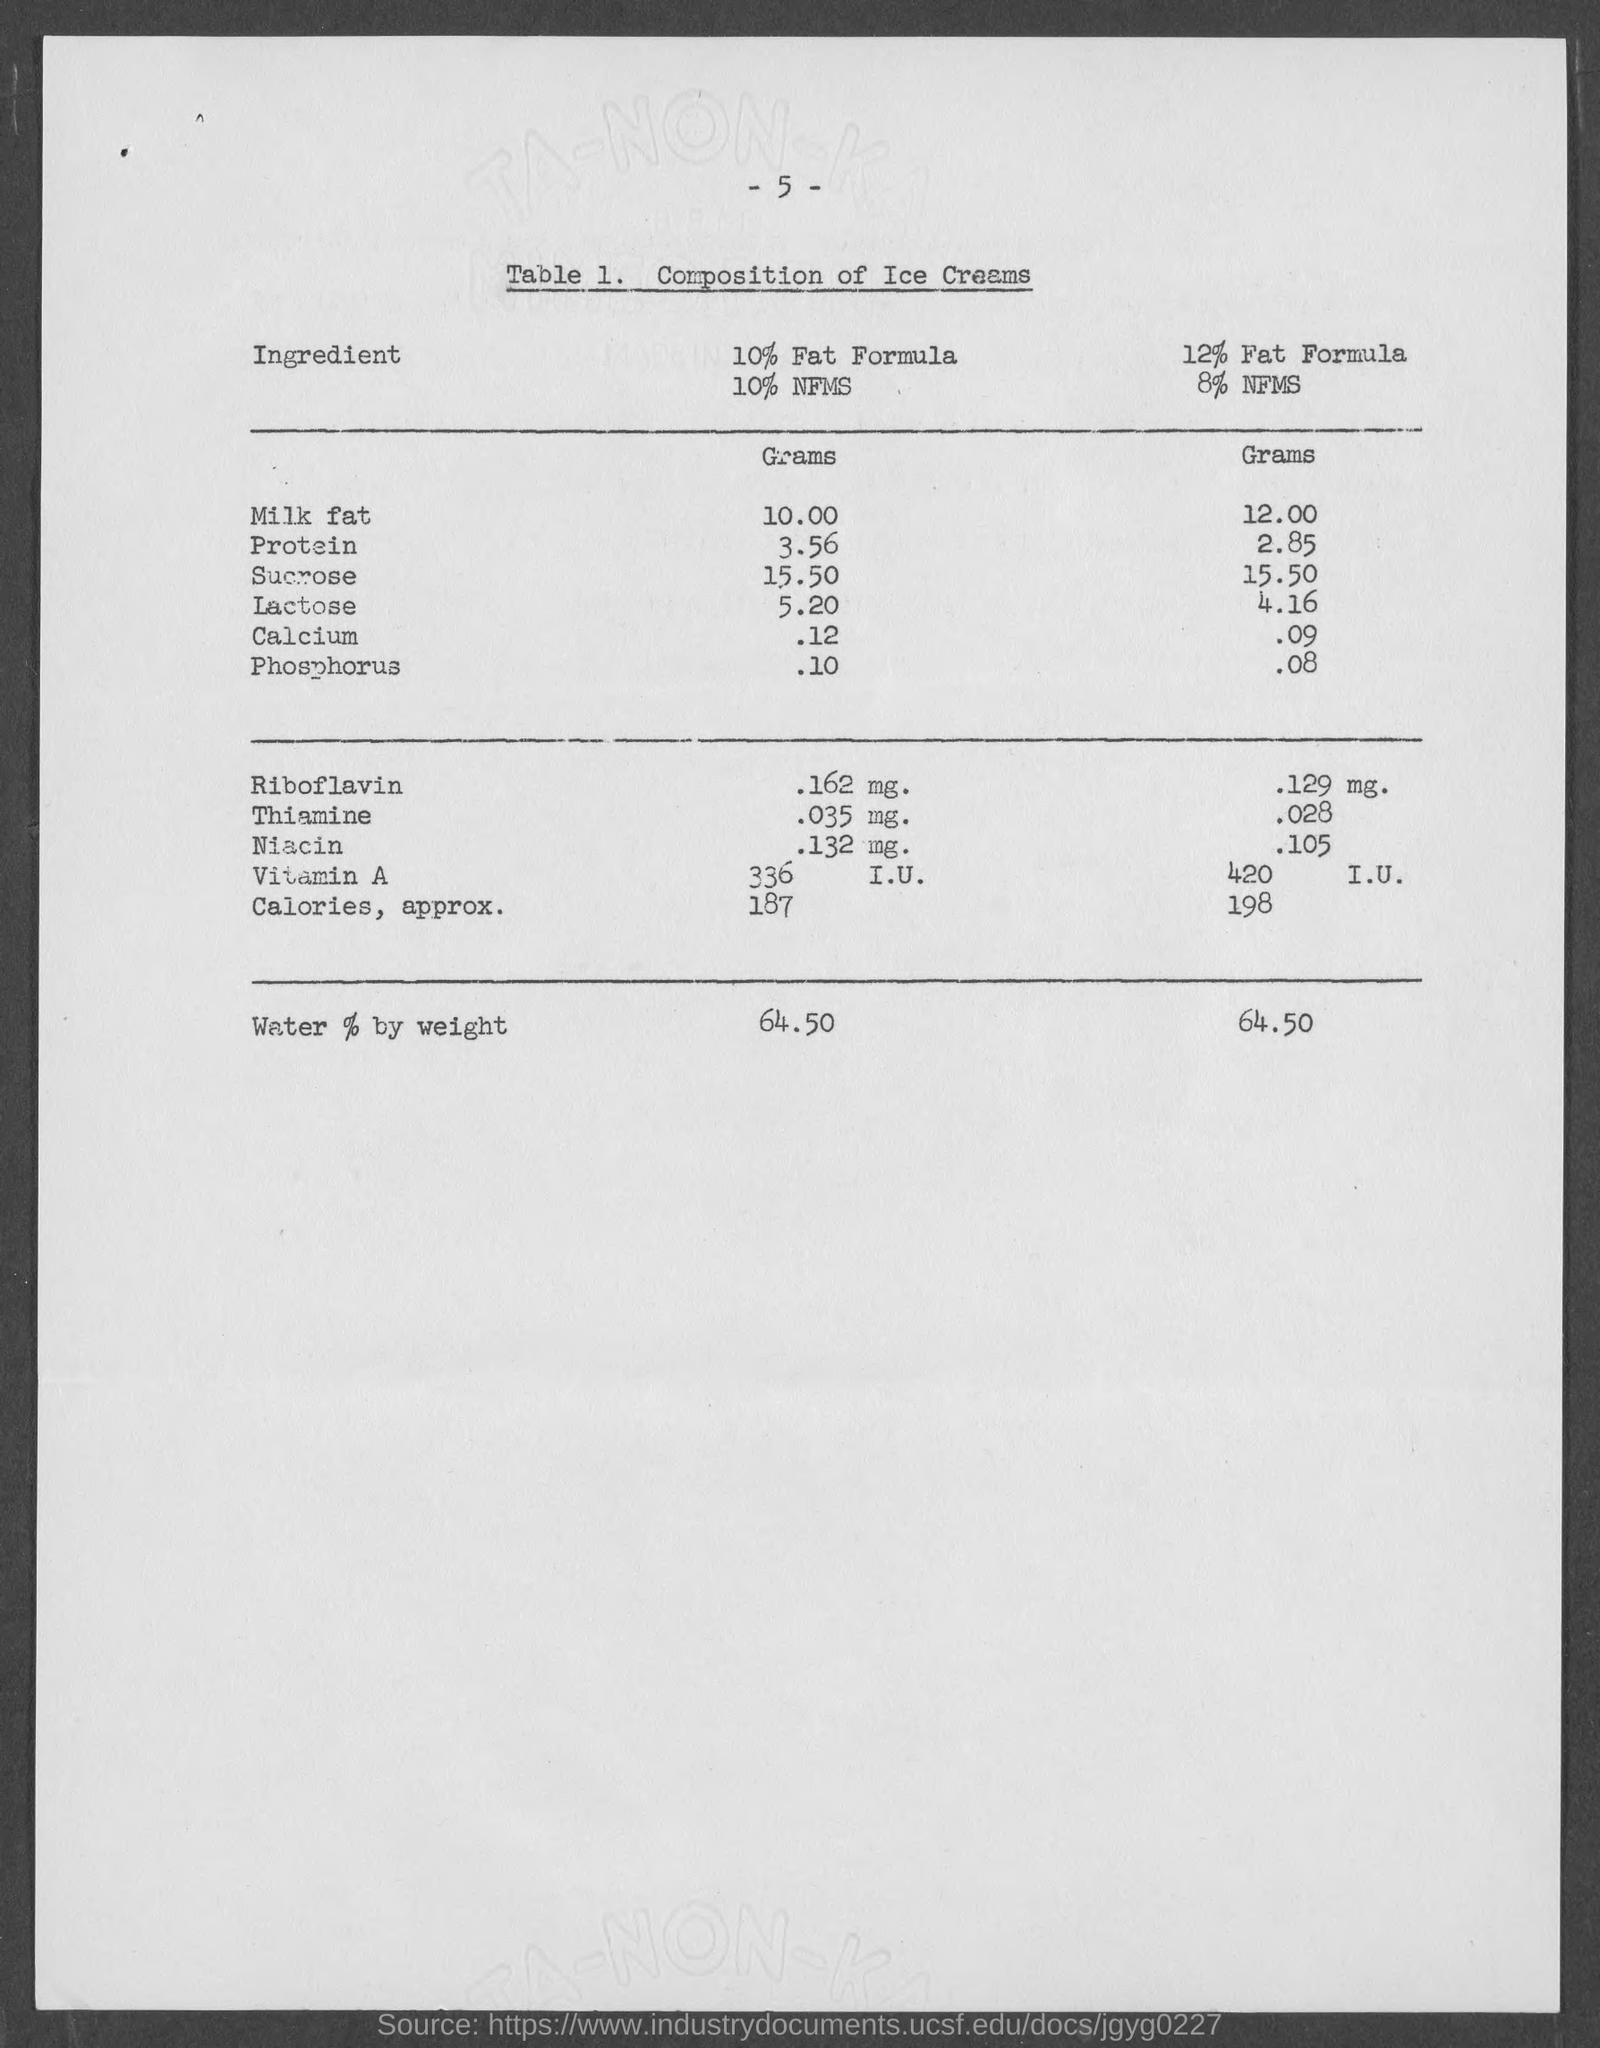Outline some significant characteristics in this image. The number at the top of the page is 5. 